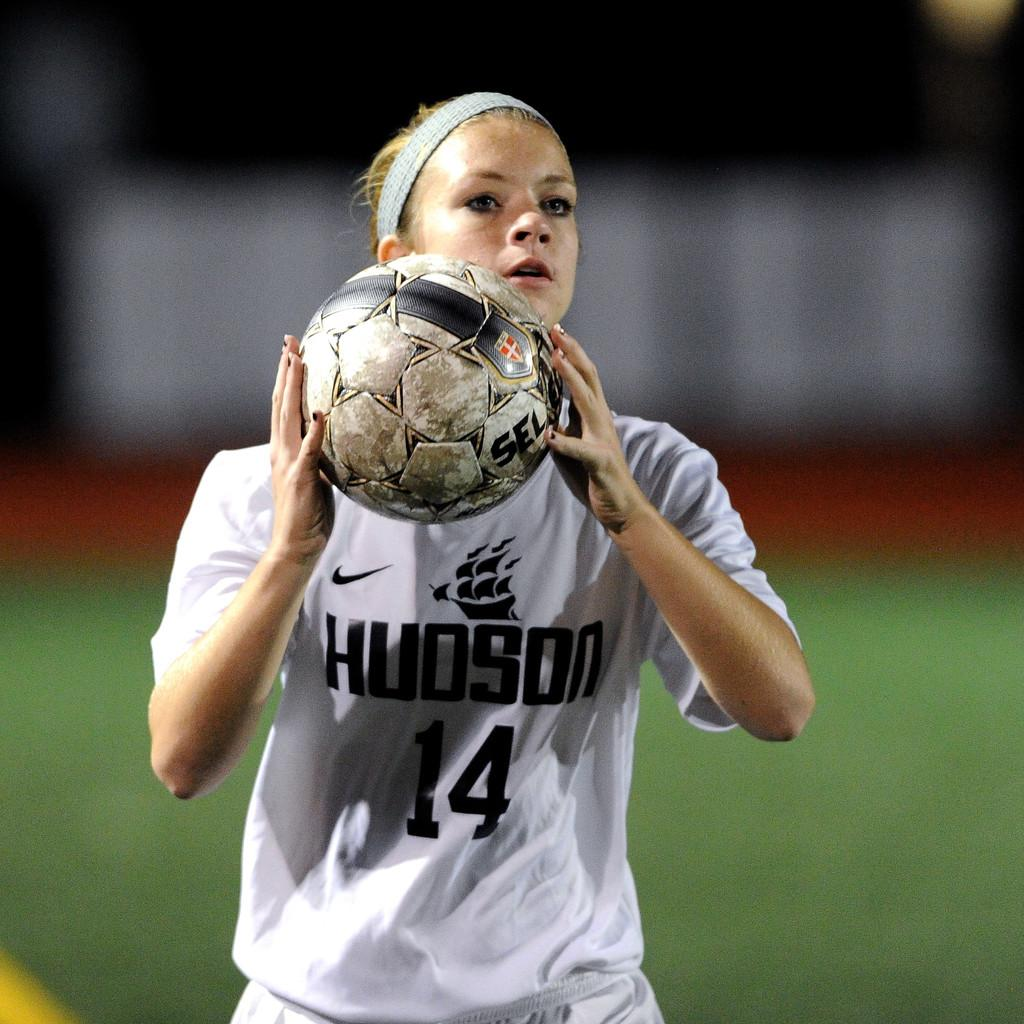Who is the main subject in the image? There is a girl in the image. What is the girl holding in her hand? The girl is holding a ball in her hand. What type of branch is the tiger holding in the image? There is no tiger or branch present in the image; it features a girl holding a ball. 